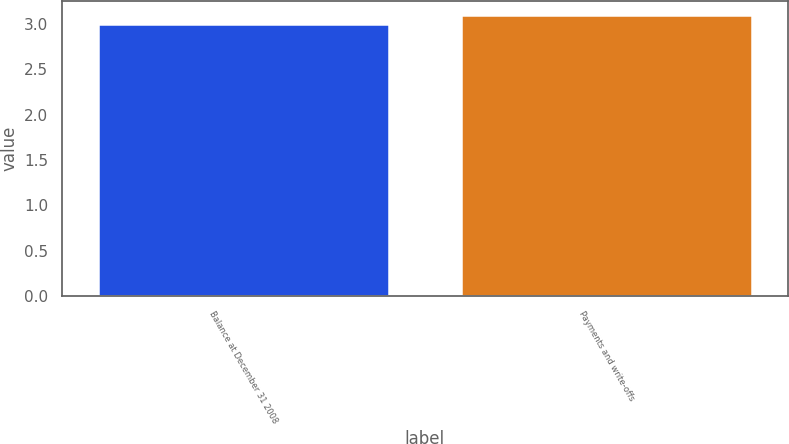<chart> <loc_0><loc_0><loc_500><loc_500><bar_chart><fcel>Balance at December 31 2008<fcel>Payments and write-offs<nl><fcel>3<fcel>3.1<nl></chart> 